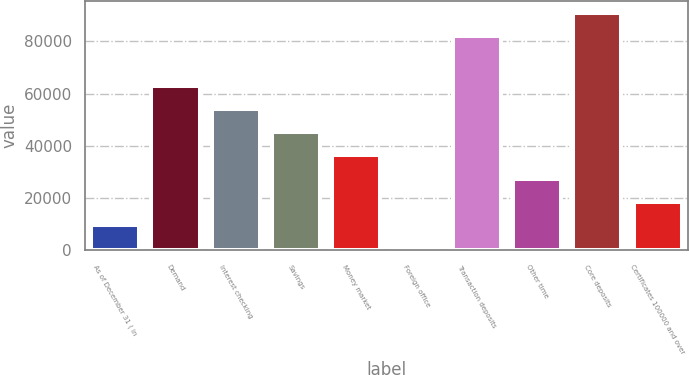Convert chart to OTSL. <chart><loc_0><loc_0><loc_500><loc_500><bar_chart><fcel>As of December 31 ( in<fcel>Demand<fcel>Interest checking<fcel>Savings<fcel>Money market<fcel>Foreign office<fcel>Transaction deposits<fcel>Other time<fcel>Core deposits<fcel>Certificates 100000 and over<nl><fcel>9748.2<fcel>62927.4<fcel>54064.2<fcel>45201<fcel>36337.8<fcel>885<fcel>82139<fcel>27474.6<fcel>91002.2<fcel>18611.4<nl></chart> 